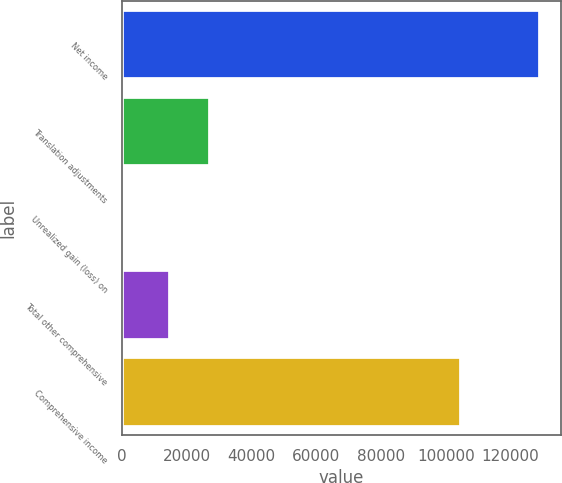<chart> <loc_0><loc_0><loc_500><loc_500><bar_chart><fcel>Net income<fcel>Translation adjustments<fcel>Unrealized gain (loss) on<fcel>Total other comprehensive<fcel>Comprehensive income<nl><fcel>129042<fcel>27073.7<fcel>42<fcel>14977<fcel>104849<nl></chart> 